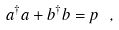Convert formula to latex. <formula><loc_0><loc_0><loc_500><loc_500>a ^ { \dagger } a + b ^ { \dagger } b = p \ ,</formula> 